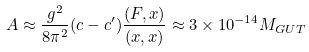<formula> <loc_0><loc_0><loc_500><loc_500>A \approx \frac { g ^ { 2 } } { 8 \pi ^ { 2 } } ( c - c ^ { \prime } ) \frac { ( F , x ) } { ( x , x ) } \approx 3 \times 1 0 ^ { - 1 4 } M _ { G U T }</formula> 